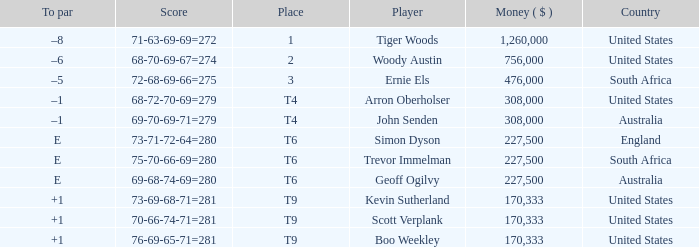What country does Tiger Woods play for? United States. 